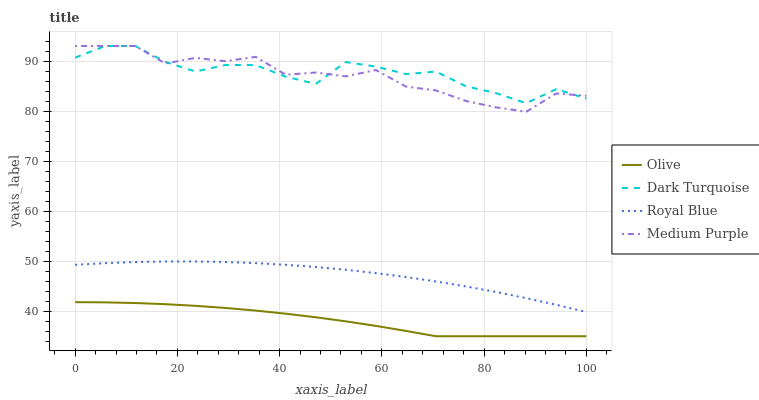Does Olive have the minimum area under the curve?
Answer yes or no. Yes. Does Dark Turquoise have the maximum area under the curve?
Answer yes or no. Yes. Does Medium Purple have the minimum area under the curve?
Answer yes or no. No. Does Medium Purple have the maximum area under the curve?
Answer yes or no. No. Is Royal Blue the smoothest?
Answer yes or no. Yes. Is Dark Turquoise the roughest?
Answer yes or no. Yes. Is Medium Purple the smoothest?
Answer yes or no. No. Is Medium Purple the roughest?
Answer yes or no. No. Does Olive have the lowest value?
Answer yes or no. Yes. Does Medium Purple have the lowest value?
Answer yes or no. No. Does Medium Purple have the highest value?
Answer yes or no. Yes. Does Royal Blue have the highest value?
Answer yes or no. No. Is Royal Blue less than Medium Purple?
Answer yes or no. Yes. Is Dark Turquoise greater than Olive?
Answer yes or no. Yes. Does Medium Purple intersect Dark Turquoise?
Answer yes or no. Yes. Is Medium Purple less than Dark Turquoise?
Answer yes or no. No. Is Medium Purple greater than Dark Turquoise?
Answer yes or no. No. Does Royal Blue intersect Medium Purple?
Answer yes or no. No. 